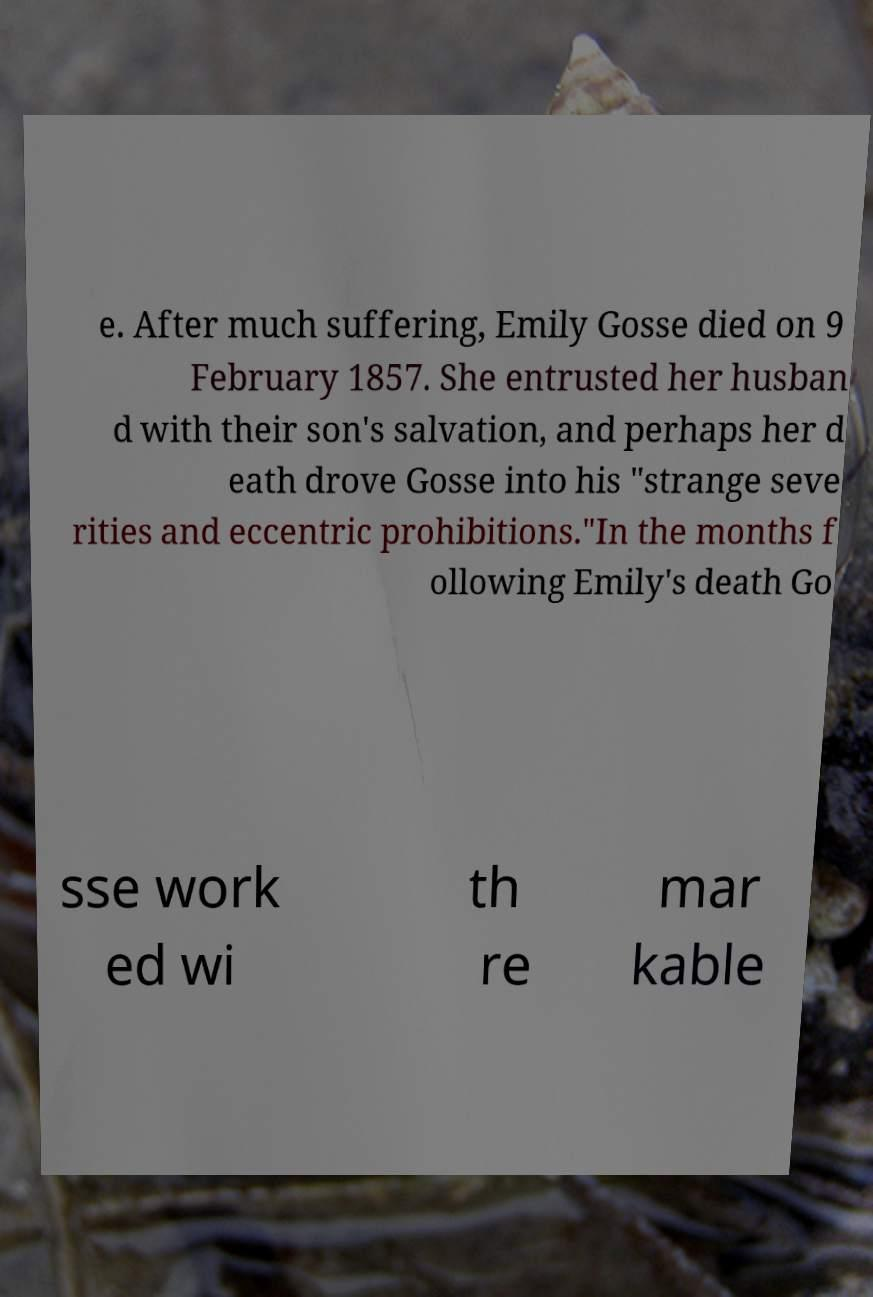Can you accurately transcribe the text from the provided image for me? e. After much suffering, Emily Gosse died on 9 February 1857. She entrusted her husban d with their son's salvation, and perhaps her d eath drove Gosse into his "strange seve rities and eccentric prohibitions."In the months f ollowing Emily's death Go sse work ed wi th re mar kable 